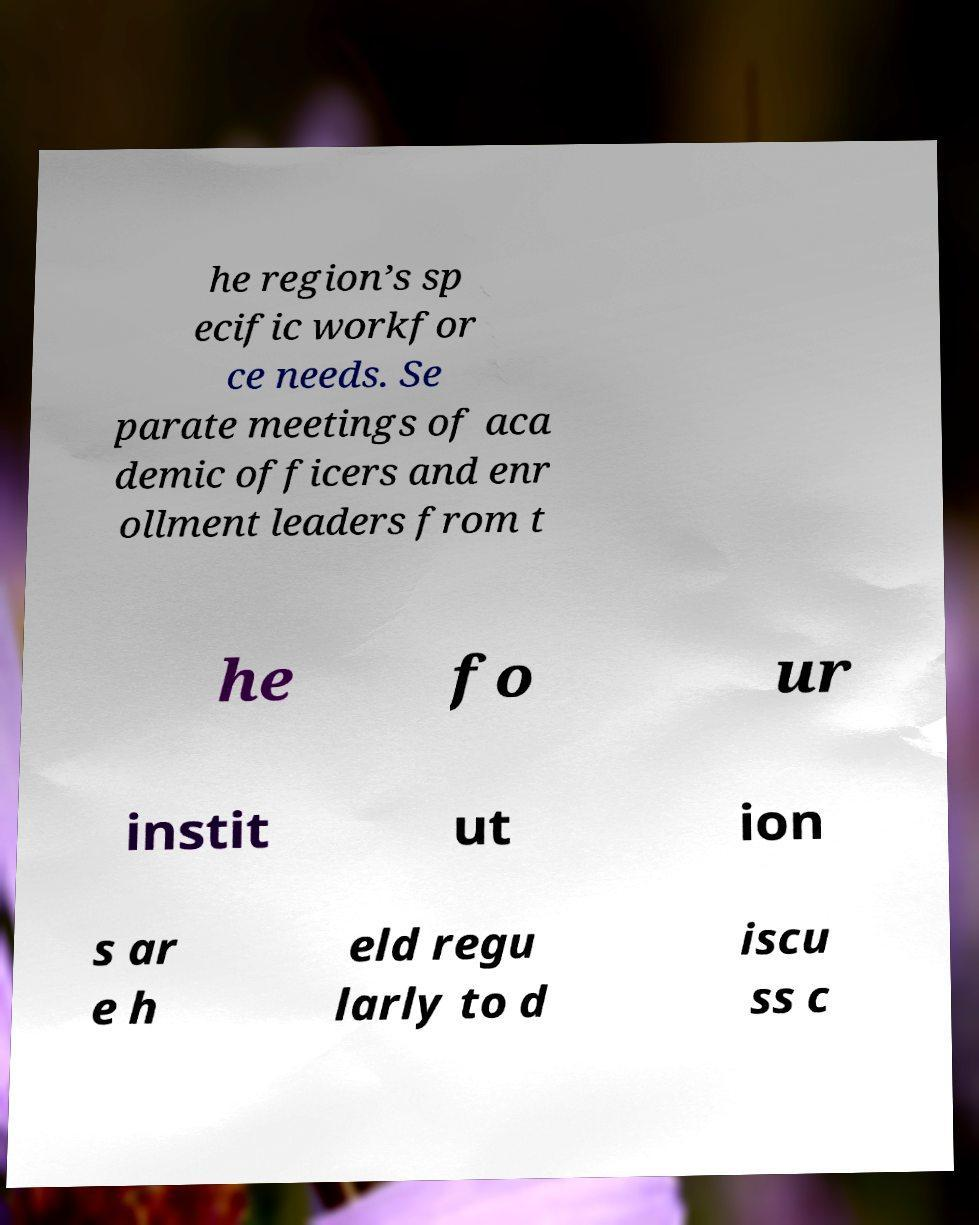I need the written content from this picture converted into text. Can you do that? he region’s sp ecific workfor ce needs. Se parate meetings of aca demic officers and enr ollment leaders from t he fo ur instit ut ion s ar e h eld regu larly to d iscu ss c 